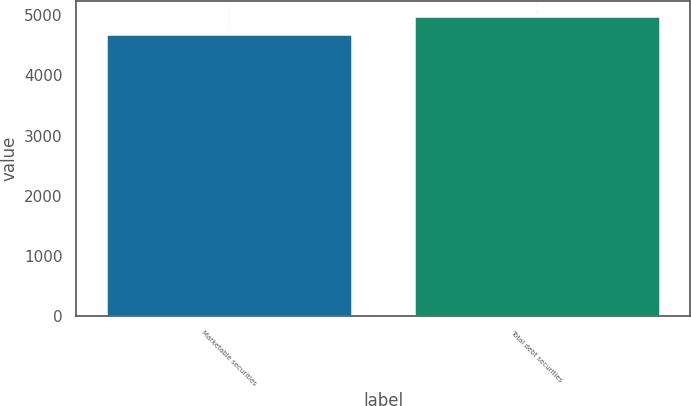Convert chart. <chart><loc_0><loc_0><loc_500><loc_500><bar_chart><fcel>Marketable securities<fcel>Total debt securities<nl><fcel>4691<fcel>4993<nl></chart> 